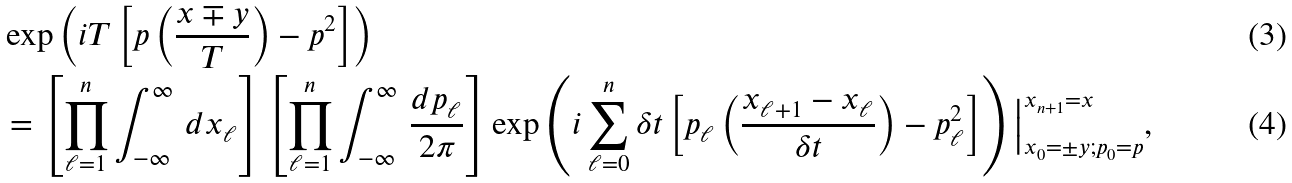<formula> <loc_0><loc_0><loc_500><loc_500>& \exp \left ( i T \left [ p \left ( \frac { x \mp y } { T } \right ) - p ^ { 2 } \right ] \right ) \\ & = \left [ \prod _ { \ell = 1 } ^ { n } \int _ { - \infty } ^ { \infty } \, d x _ { \ell } \right ] \left [ \prod _ { \ell = 1 } ^ { n } \int _ { - \infty } ^ { \infty } \, \frac { d p _ { \ell } } { 2 \pi } \right ] \exp \left ( i \sum _ { \ell = 0 } ^ { n } \delta t \left [ p _ { \ell } \left ( \frac { x _ { \ell + 1 } - x _ { \ell } } { \delta t } \right ) - p _ { \ell } ^ { 2 } \right ] \right ) \Big | _ { x _ { 0 } = \pm y ; p _ { 0 } = p } ^ { x _ { n + 1 } = x } ,</formula> 